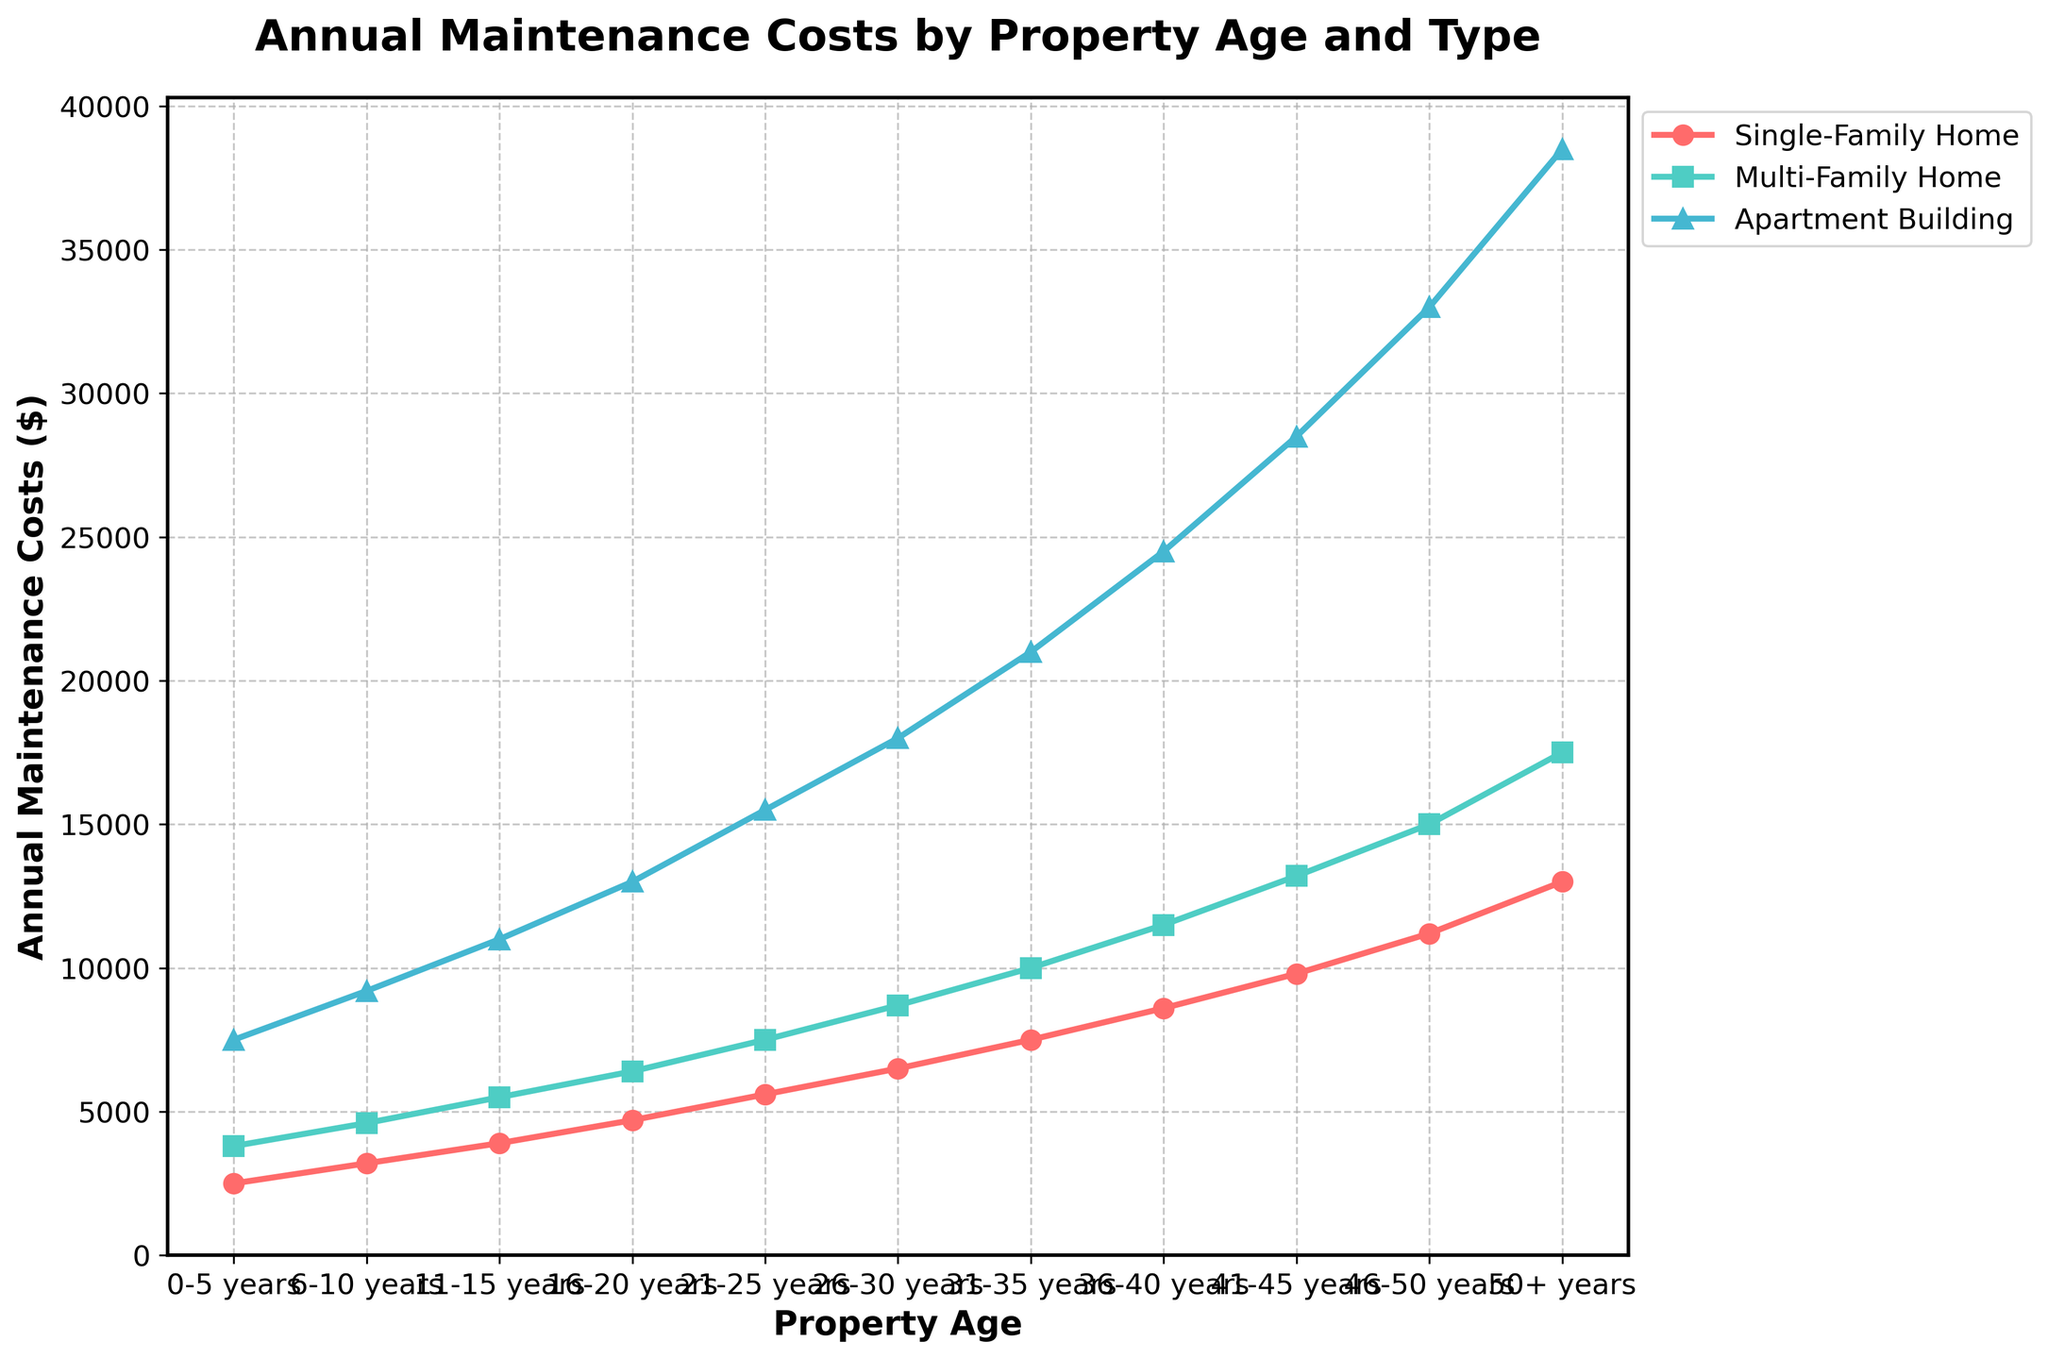What's the difference in annual maintenance costs for single-family homes and apartment buildings for properties aged 26-30 years? To find the difference, subtract the maintenance cost of single-family homes from that of apartment buildings for the age group 26-30 years: 18000 - 6500 = 11500
Answer: 11500 Which property type has the highest increase in maintenance costs from the 0-5 years age group to the 50+ years age group? Calculate the increase for each property type:
- Single-Family Home: 13000 - 2500 = 10500
- Multi-Family Home: 17500 - 3800 = 13700
- Apartment Building: 38500 - 7500 = 31000
The apartment building has the highest increase.
Answer: Apartment Building What is the average annual maintenance cost for multi-family homes across all property ages? Add the maintenance costs for multi-family homes across all age groups: 3800 + 4600 + 5500 + 6400 + 7500 + 8700 + 10000 + 11500 + 13200 + 15000 + 17500 = 103700. Divide by the number of groups (11): 103700 / 11 = 9436.36
Answer: 9436.36 Are maintenance costs for multi-family homes always higher than single-family homes across all property ages? Compare the maintenance costs for multi-family homes and single-family homes for each property age group:
- 0-5 years: 3800 > 2500
- 6-10 years: 4600 > 3200
- 11-15 years: 5500 > 3900
- 16-20 years: 6400 > 4700
- 21-25 years: 7500 > 5600
- 26-30 years: 8700 > 6500
- 31-35 years: 10000 > 7500
- 36-40 years: 11500 > 8600
- 41-45 years: 13200 > 9800
- 46-50 years: 15000 > 11200
- 50+ years: 17500 > 13000
In all age groups, multi-family home costs are higher.
Answer: Yes What is the percentage increase in annual maintenance cost for apartment buildings from 21-25 years to 50+ years? Calculate the increase: 38500 - 15500 = 23000. Then find the percentage increase: (23000 / 15500) * 100 = 148.39%
Answer: 148.39% Which property type has the least annual maintenance cost at the 41-45 years age group? Compare the maintenance costs at the 41-45 years age group:
- Single-Family Home: 9800
- Multi-Family Home: 13200
- Apartment Building: 28500
The single-family home has the least cost.
Answer: Single-Family Home At which property age does the maintenance cost for single-family homes first exceed $10,000? Look for the first property age group where the single-family home cost exceeds $10,000: 
- 41-45 years: 9800 (not exceeding)
- 46-50 years: 11200 (exceeding)
The first age group is 46-50 years.
Answer: 46-50 years How do the maintenance costs for apartments compare visually with other property types as they age? Visually observe the plot: The line for apartment buildings rises more steeply and is consistently higher than those for single-family homes and multi-family homes, indicating that apartment buildings have higher maintenance costs as they age.
Answer: Apartment buildings are higher 